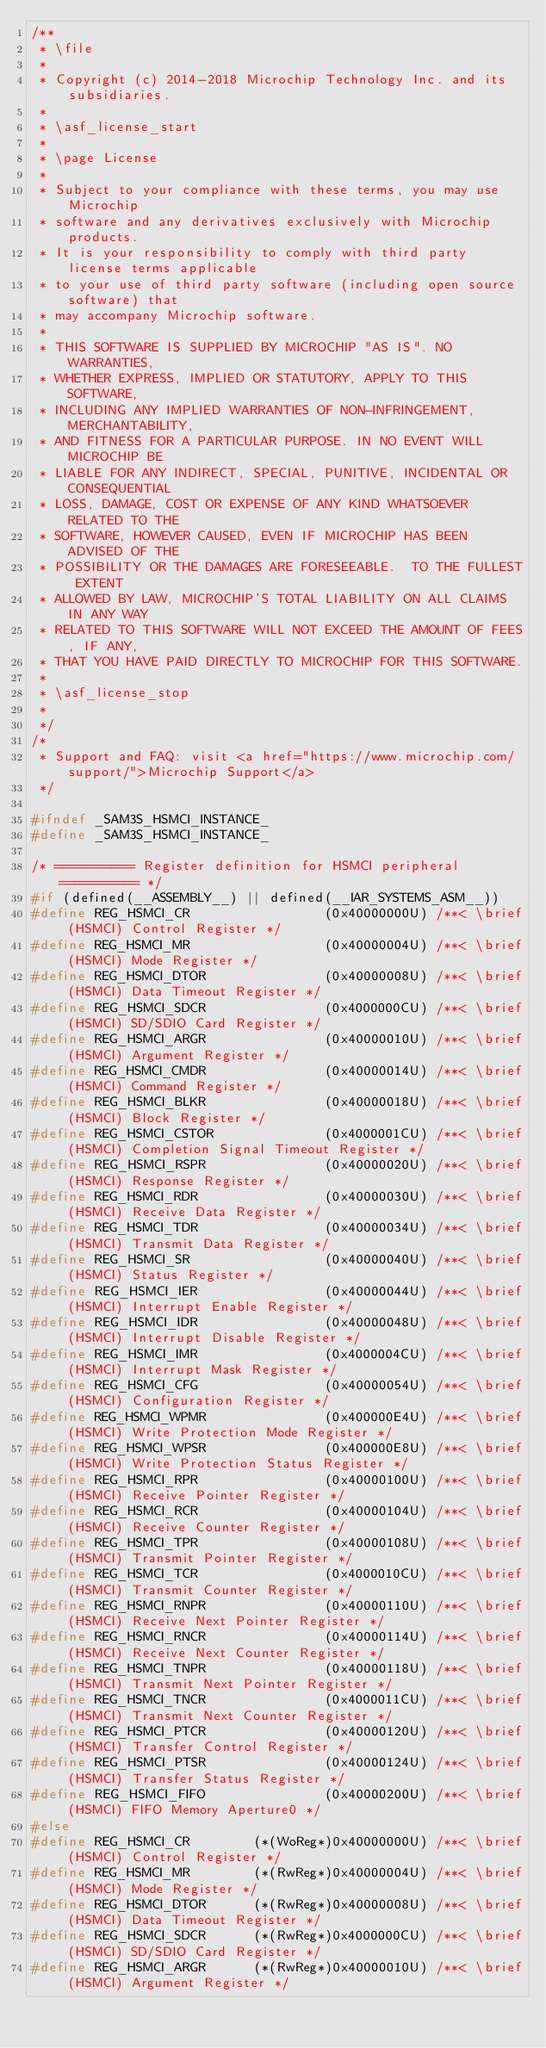Convert code to text. <code><loc_0><loc_0><loc_500><loc_500><_C_>/**
 * \file
 *
 * Copyright (c) 2014-2018 Microchip Technology Inc. and its subsidiaries.
 *
 * \asf_license_start
 *
 * \page License
 *
 * Subject to your compliance with these terms, you may use Microchip
 * software and any derivatives exclusively with Microchip products.
 * It is your responsibility to comply with third party license terms applicable
 * to your use of third party software (including open source software) that
 * may accompany Microchip software.
 *
 * THIS SOFTWARE IS SUPPLIED BY MICROCHIP "AS IS". NO WARRANTIES,
 * WHETHER EXPRESS, IMPLIED OR STATUTORY, APPLY TO THIS SOFTWARE,
 * INCLUDING ANY IMPLIED WARRANTIES OF NON-INFRINGEMENT, MERCHANTABILITY,
 * AND FITNESS FOR A PARTICULAR PURPOSE. IN NO EVENT WILL MICROCHIP BE
 * LIABLE FOR ANY INDIRECT, SPECIAL, PUNITIVE, INCIDENTAL OR CONSEQUENTIAL
 * LOSS, DAMAGE, COST OR EXPENSE OF ANY KIND WHATSOEVER RELATED TO THE
 * SOFTWARE, HOWEVER CAUSED, EVEN IF MICROCHIP HAS BEEN ADVISED OF THE
 * POSSIBILITY OR THE DAMAGES ARE FORESEEABLE.  TO THE FULLEST EXTENT
 * ALLOWED BY LAW, MICROCHIP'S TOTAL LIABILITY ON ALL CLAIMS IN ANY WAY
 * RELATED TO THIS SOFTWARE WILL NOT EXCEED THE AMOUNT OF FEES, IF ANY,
 * THAT YOU HAVE PAID DIRECTLY TO MICROCHIP FOR THIS SOFTWARE.
 *
 * \asf_license_stop
 *
 */
/*
 * Support and FAQ: visit <a href="https://www.microchip.com/support/">Microchip Support</a>
 */

#ifndef _SAM3S_HSMCI_INSTANCE_
#define _SAM3S_HSMCI_INSTANCE_

/* ========== Register definition for HSMCI peripheral ========== */
#if (defined(__ASSEMBLY__) || defined(__IAR_SYSTEMS_ASM__))
#define REG_HSMCI_CR                 (0x40000000U) /**< \brief (HSMCI) Control Register */
#define REG_HSMCI_MR                 (0x40000004U) /**< \brief (HSMCI) Mode Register */
#define REG_HSMCI_DTOR               (0x40000008U) /**< \brief (HSMCI) Data Timeout Register */
#define REG_HSMCI_SDCR               (0x4000000CU) /**< \brief (HSMCI) SD/SDIO Card Register */
#define REG_HSMCI_ARGR               (0x40000010U) /**< \brief (HSMCI) Argument Register */
#define REG_HSMCI_CMDR               (0x40000014U) /**< \brief (HSMCI) Command Register */
#define REG_HSMCI_BLKR               (0x40000018U) /**< \brief (HSMCI) Block Register */
#define REG_HSMCI_CSTOR              (0x4000001CU) /**< \brief (HSMCI) Completion Signal Timeout Register */
#define REG_HSMCI_RSPR               (0x40000020U) /**< \brief (HSMCI) Response Register */
#define REG_HSMCI_RDR                (0x40000030U) /**< \brief (HSMCI) Receive Data Register */
#define REG_HSMCI_TDR                (0x40000034U) /**< \brief (HSMCI) Transmit Data Register */
#define REG_HSMCI_SR                 (0x40000040U) /**< \brief (HSMCI) Status Register */
#define REG_HSMCI_IER                (0x40000044U) /**< \brief (HSMCI) Interrupt Enable Register */
#define REG_HSMCI_IDR                (0x40000048U) /**< \brief (HSMCI) Interrupt Disable Register */
#define REG_HSMCI_IMR                (0x4000004CU) /**< \brief (HSMCI) Interrupt Mask Register */
#define REG_HSMCI_CFG                (0x40000054U) /**< \brief (HSMCI) Configuration Register */
#define REG_HSMCI_WPMR               (0x400000E4U) /**< \brief (HSMCI) Write Protection Mode Register */
#define REG_HSMCI_WPSR               (0x400000E8U) /**< \brief (HSMCI) Write Protection Status Register */
#define REG_HSMCI_RPR                (0x40000100U) /**< \brief (HSMCI) Receive Pointer Register */
#define REG_HSMCI_RCR                (0x40000104U) /**< \brief (HSMCI) Receive Counter Register */
#define REG_HSMCI_TPR                (0x40000108U) /**< \brief (HSMCI) Transmit Pointer Register */
#define REG_HSMCI_TCR                (0x4000010CU) /**< \brief (HSMCI) Transmit Counter Register */
#define REG_HSMCI_RNPR               (0x40000110U) /**< \brief (HSMCI) Receive Next Pointer Register */
#define REG_HSMCI_RNCR               (0x40000114U) /**< \brief (HSMCI) Receive Next Counter Register */
#define REG_HSMCI_TNPR               (0x40000118U) /**< \brief (HSMCI) Transmit Next Pointer Register */
#define REG_HSMCI_TNCR               (0x4000011CU) /**< \brief (HSMCI) Transmit Next Counter Register */
#define REG_HSMCI_PTCR               (0x40000120U) /**< \brief (HSMCI) Transfer Control Register */
#define REG_HSMCI_PTSR               (0x40000124U) /**< \brief (HSMCI) Transfer Status Register */
#define REG_HSMCI_FIFO               (0x40000200U) /**< \brief (HSMCI) FIFO Memory Aperture0 */
#else
#define REG_HSMCI_CR        (*(WoReg*)0x40000000U) /**< \brief (HSMCI) Control Register */
#define REG_HSMCI_MR        (*(RwReg*)0x40000004U) /**< \brief (HSMCI) Mode Register */
#define REG_HSMCI_DTOR      (*(RwReg*)0x40000008U) /**< \brief (HSMCI) Data Timeout Register */
#define REG_HSMCI_SDCR      (*(RwReg*)0x4000000CU) /**< \brief (HSMCI) SD/SDIO Card Register */
#define REG_HSMCI_ARGR      (*(RwReg*)0x40000010U) /**< \brief (HSMCI) Argument Register */</code> 